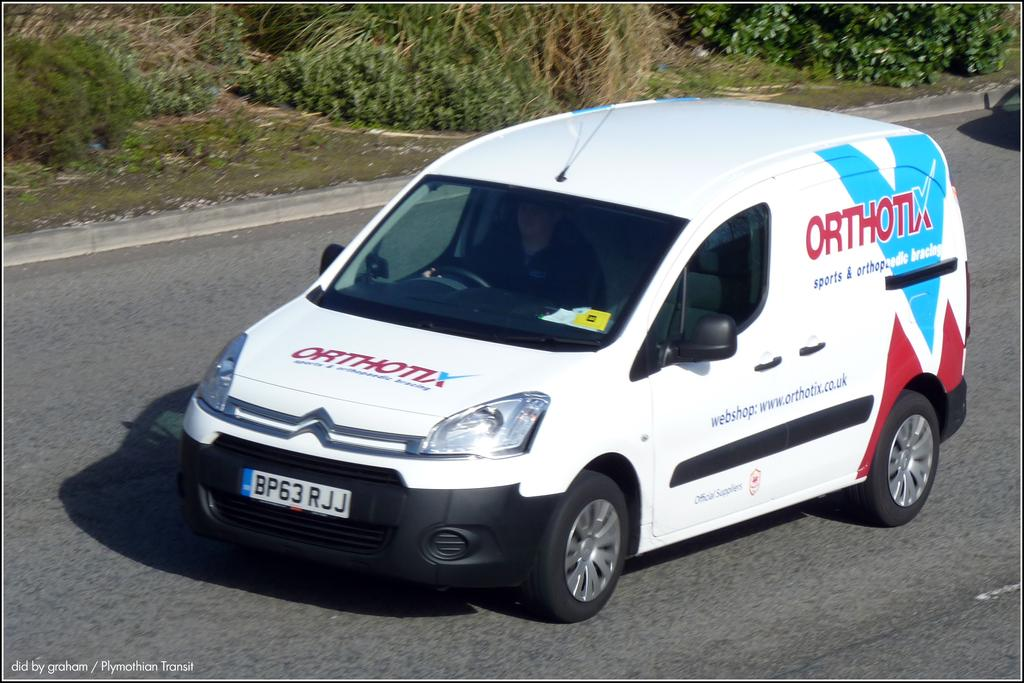<image>
Render a clear and concise summary of the photo. A white van with the company logo for ORTHORIX 